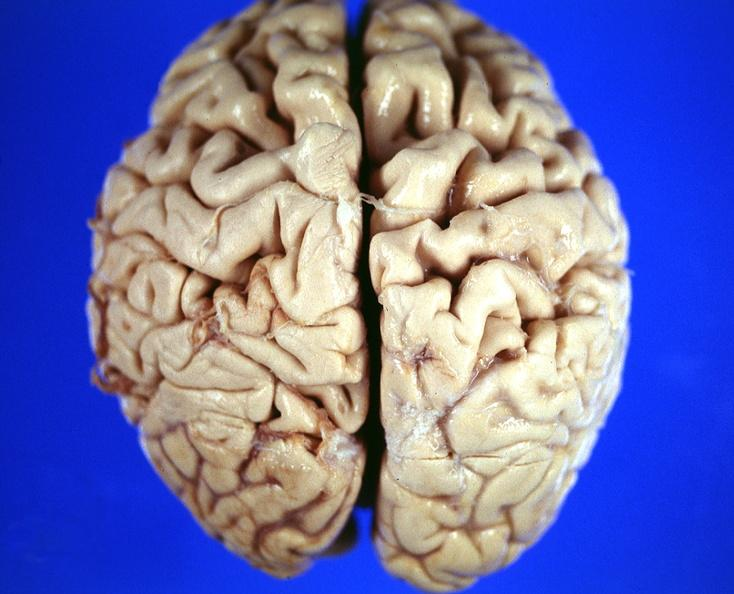s nervous present?
Answer the question using a single word or phrase. Yes 